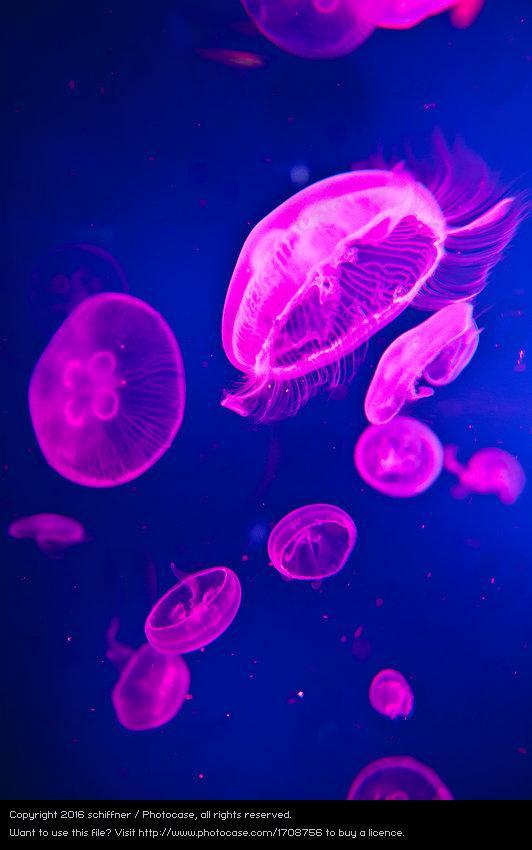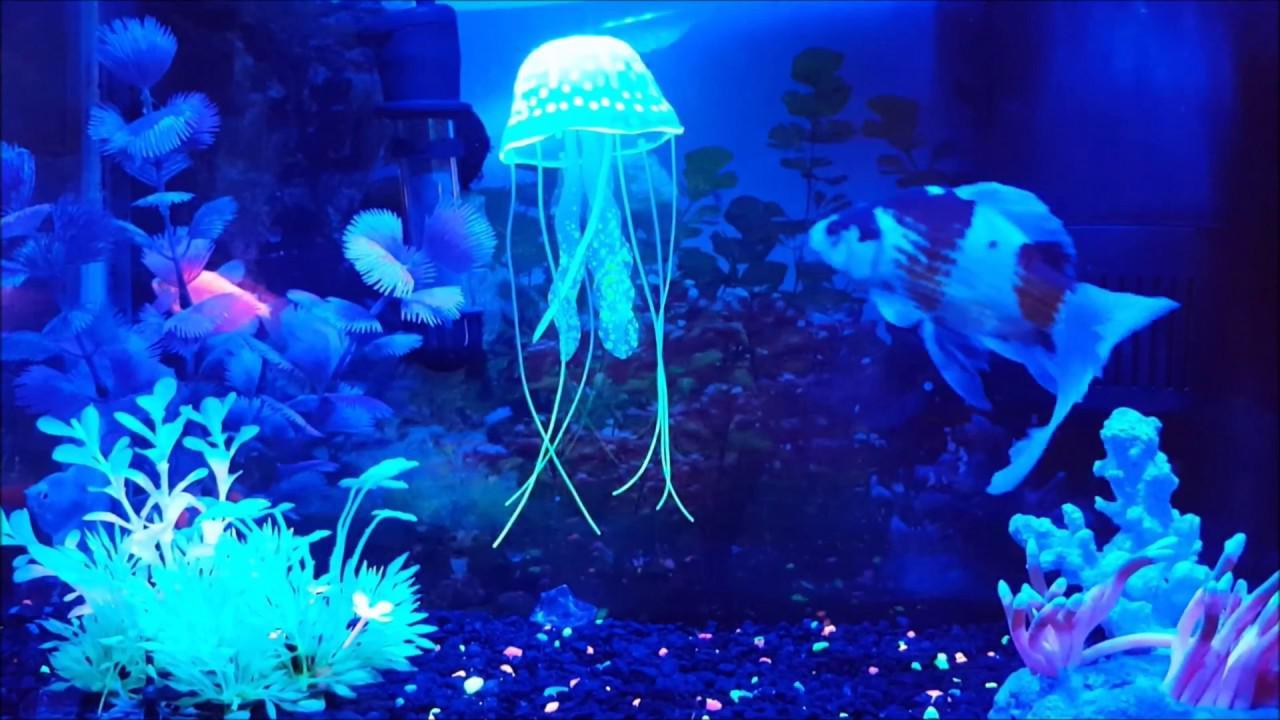The first image is the image on the left, the second image is the image on the right. Assess this claim about the two images: "Exactly one image shows multiple hot pink jellyfish on a blue backdrop.". Correct or not? Answer yes or no. Yes. The first image is the image on the left, the second image is the image on the right. Considering the images on both sides, is "There is a single upright jellyfish in one of the images." valid? Answer yes or no. Yes. 